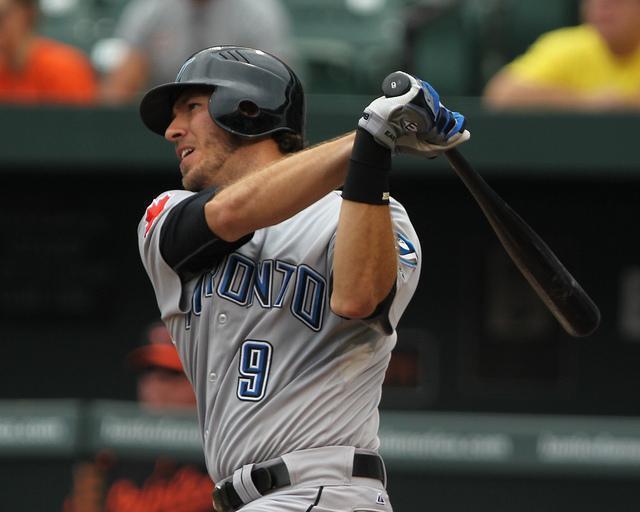How many people are there?
Give a very brief answer. 5. 